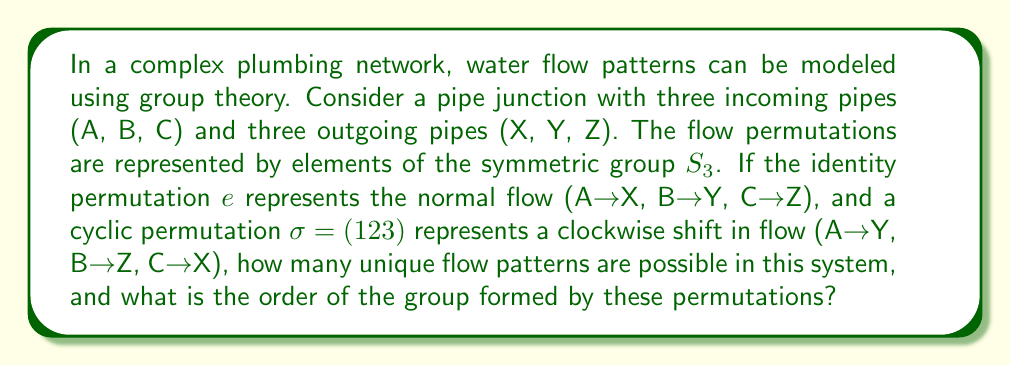Give your solution to this math problem. To solve this problem, we need to analyze the group structure of the water flow patterns:

1) First, let's identify the elements of the group:
   - $e$ : Identity permutation (A→X, B→Y, C→Z)
   - $\sigma$ : Clockwise shift (A→Y, B→Z, C→X)
   - $\sigma^2$ : Double clockwise shift (A→Z, B→X, C→Y)
   - $\tau$ : Transposition (A→Y, B→X, C→Z)
   - $\tau\sigma$ : Transposition followed by clockwise shift (A→X, B→Z, C→Y)
   - $\tau\sigma^2$ : Transposition followed by double clockwise shift (A→Z, B→Y, C→X)

2) These six permutations form all possible unique flow patterns in the system.

3) The group formed by these permutations is isomorphic to $S_3$, the symmetric group on 3 elements.

4) To determine the order of the group, we simply count the number of elements, which is 6.

5) We can verify that this set of permutations satisfies the group axioms:
   - Closure: Combining any two permutations results in another permutation in the set.
   - Associativity: This is inherent in permutations.
   - Identity: The permutation $e$ serves as the identity element.
   - Inverse: Each permutation has an inverse in the set.

Therefore, the group of water flow patterns in this pipe network forms a group of order 6, isomorphic to $S_3$.
Answer: There are 6 unique flow patterns possible, and the order of the group formed by these permutations is 6. 